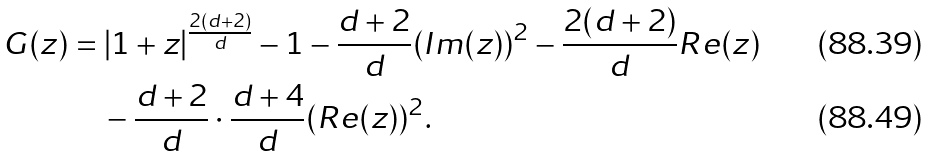<formula> <loc_0><loc_0><loc_500><loc_500>G ( z ) & = | 1 + z | ^ { \frac { 2 ( d + 2 ) } d } - 1 - \frac { d + 2 } d ( I m ( z ) ) ^ { 2 } - \frac { 2 ( d + 2 ) } d R e ( z ) \\ & \quad - \frac { d + 2 } d \cdot \frac { d + 4 } d ( R e ( z ) ) ^ { 2 } .</formula> 